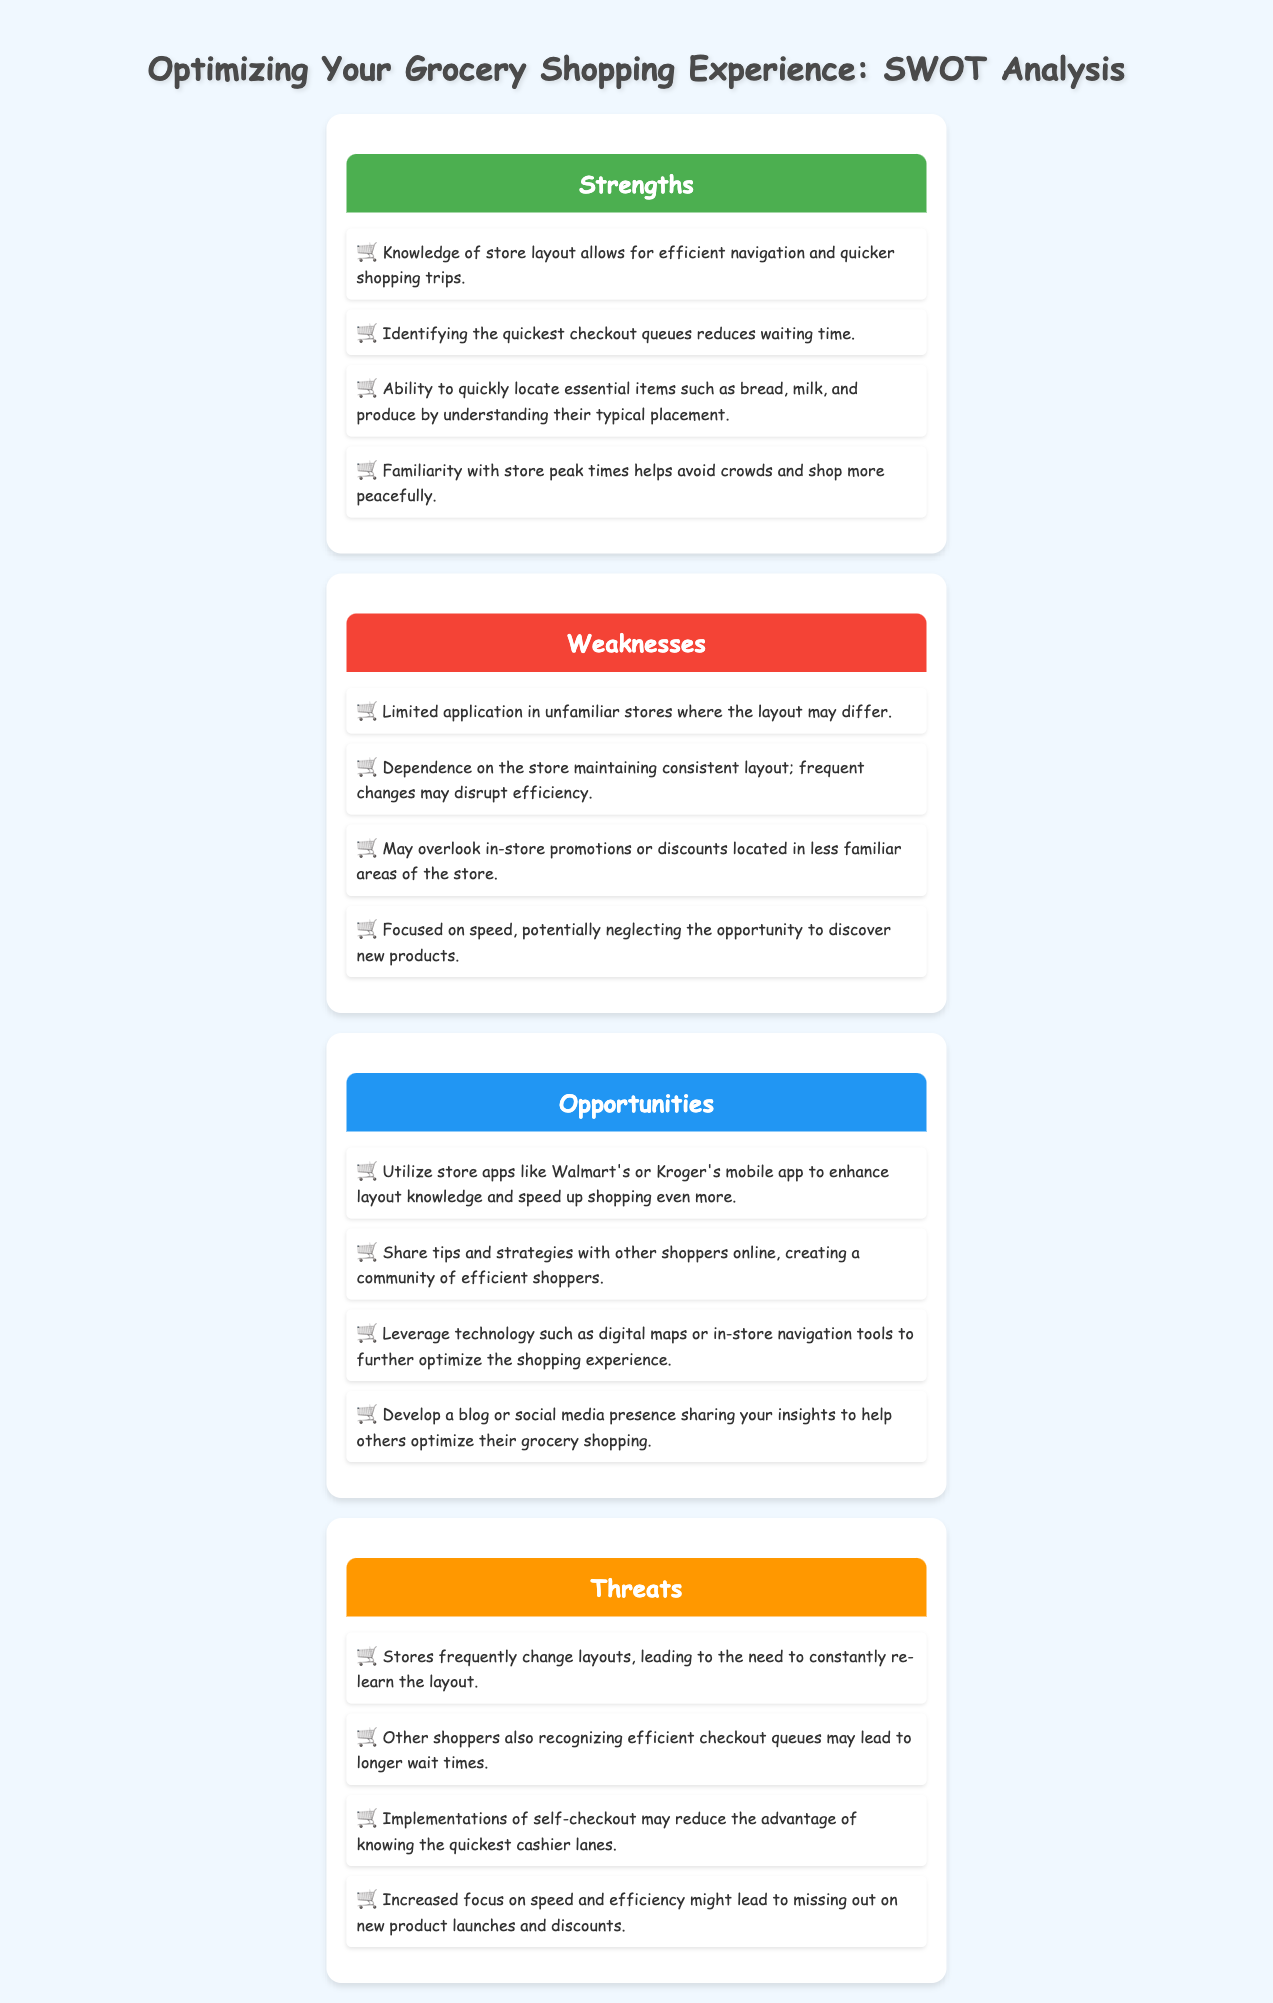What is one strength of grocery shopping knowledge? The strength is that it allows for efficient navigation and quicker shopping trips.
Answer: Efficient navigation and quicker shopping trips What is a weakness related to store layout consistency? The weakness is dependence on the store maintaining a consistent layout; frequent changes may disrupt efficiency.
Answer: Dependence on the store maintaining consistent layout What opportunity involves technology? The opportunity is to leverage technology such as digital maps or in-store navigation tools to optimize the shopping experience.
Answer: Leverage technology such as digital maps What is a potential threat from store layouts? A threat is that stores frequently change layouts, leading to the need to constantly re-learn the layout.
Answer: Stores frequently change layouts How many strengths are listed in the document? The number of strengths listed in the document is four.
Answer: Four Which shopping apps are mentioned as opportunities? The shopping apps mentioned are Walmart's and Kroger's mobile app.
Answer: Walmart's and Kroger's mobile app What can be overseen according to the weaknesses? In-store promotions or discounts located in less familiar areas of the store can be overlooked.
Answer: In-store promotions or discounts What is a reason for longer wait times? A reason for longer wait times is that other shoppers also recognizing efficient checkout queues.
Answer: Other shoppers also recognizing efficient checkout queues 